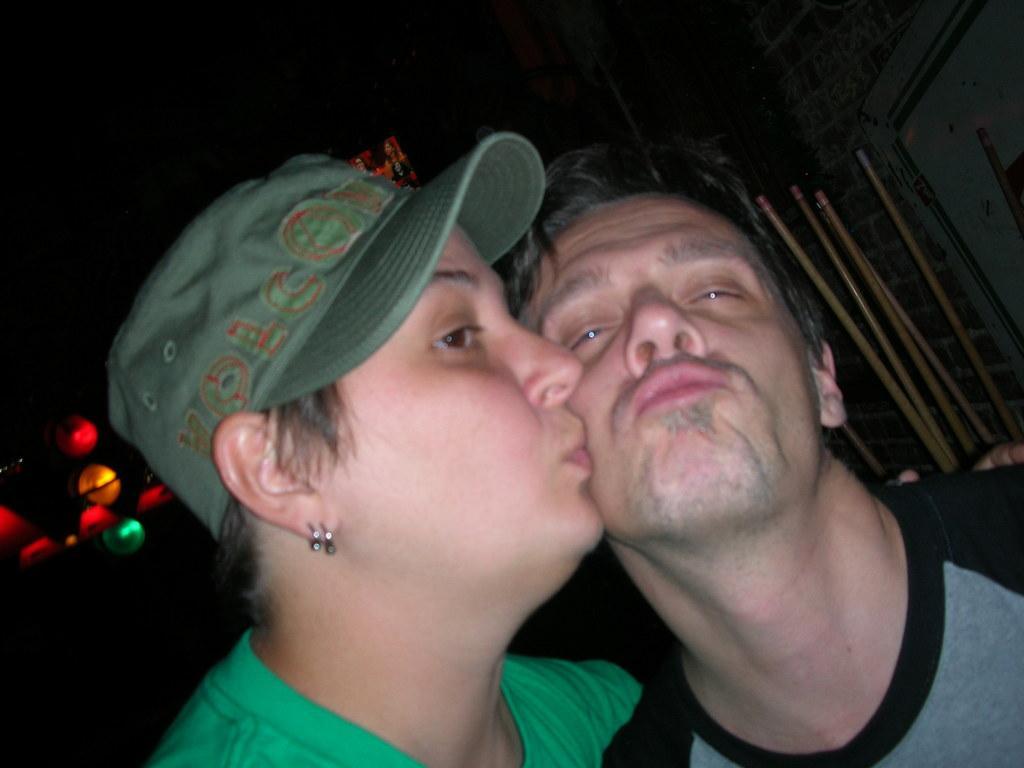Could you give a brief overview of what you see in this image? In this image I can see two persons in the front and I can see one of them is wearing a cap. On the left side of this image I can see number of lights and on the right side I can see few sticks. 